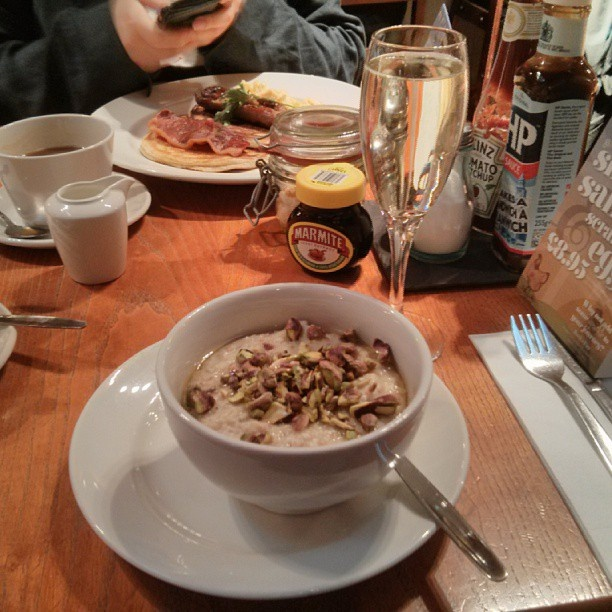Describe the objects in this image and their specific colors. I can see dining table in black, darkgray, brown, gray, and maroon tones, bowl in black, gray, maroon, and tan tones, people in black, gray, and brown tones, wine glass in black, gray, tan, and brown tones, and bottle in black, gray, and maroon tones in this image. 